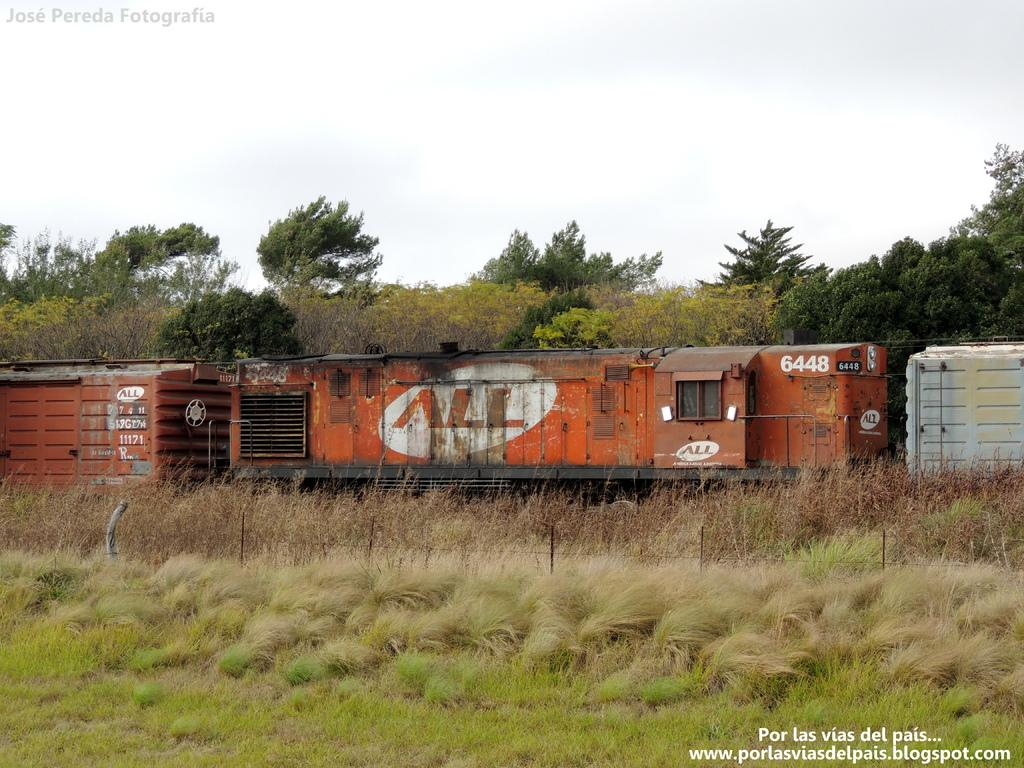What is the main subject of the picture? The main subject of the picture is a train. What can be seen in the foreground of the picture? There is a fence and grass in the foreground of the picture. What type of vegetation is present in the picture? There are plants and trees in the picture. What is visible in the background of the picture? The sky is visible in the background of the picture. Are there any watermarks on the image? Yes, there are watermarks on the image. What type of dress is the train wearing in the picture? Trains do not wear dresses; they are inanimate objects. 